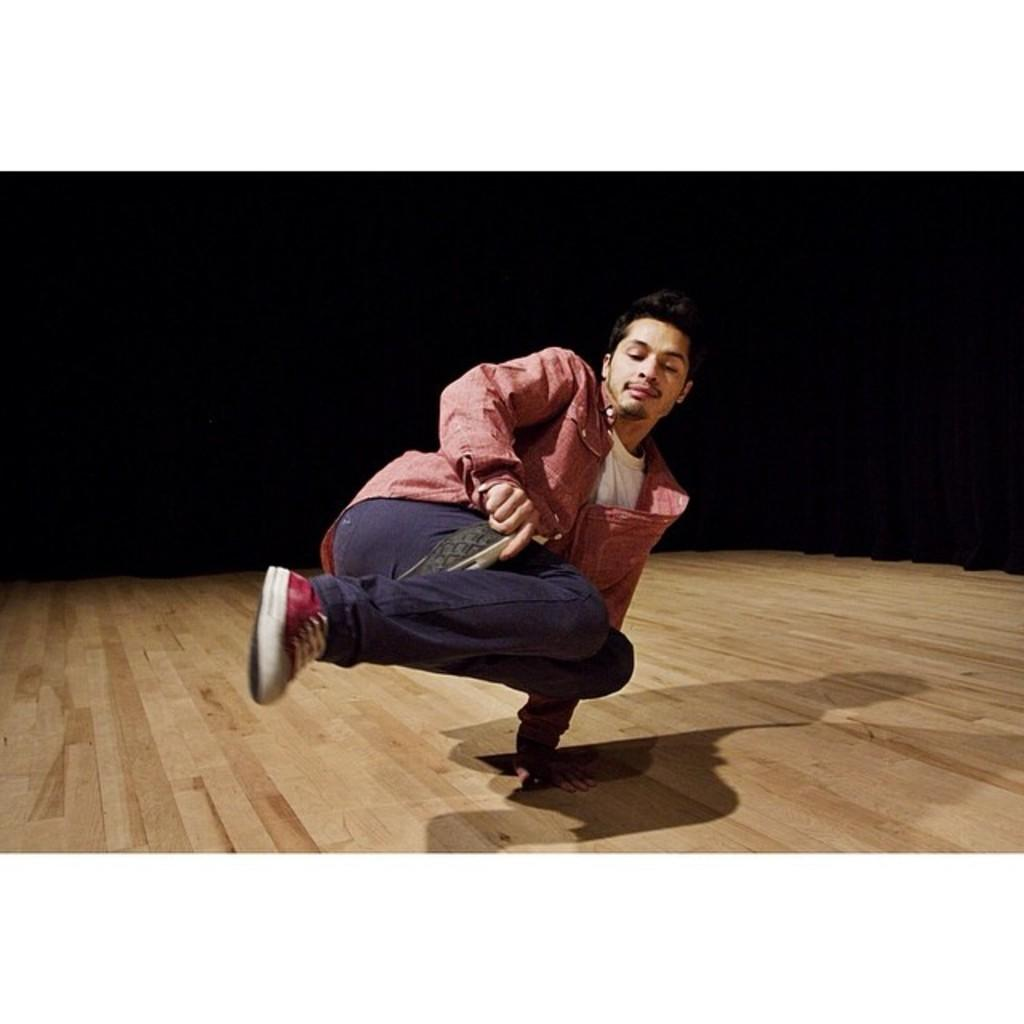What is happening in the image? There is a person in the image performing a stunt. Can you describe the person's actions in the image? The person is performing a stunt, which involves a specific action or skill. What type of hearing aid is the person using in the image? There is no indication in the image that the person is using a hearing aid, as the focus is on the person performing a stunt. Is the person riding a bike in the image? There is no mention of a bike in the image, and the focus is on the person performing a stunt. 